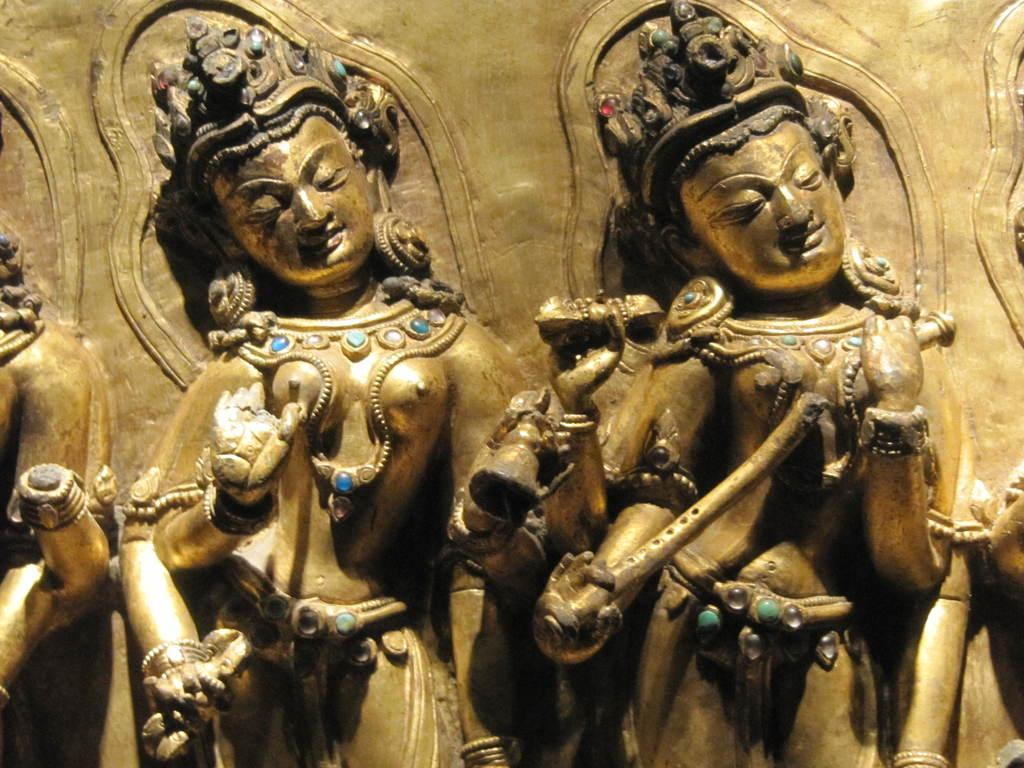What type of objects can be seen in the image? There are sculptures in the image. What is the color of the sculptures? The sculptures are gold in color. What type of bird can be seen perched on the sculpture in the image? There is no bird present in the image; it only features gold-colored sculptures. What scent is associated with the sculptures in the image? The image does not provide any information about the scent of the sculptures, as it only focuses on their visual appearance. 